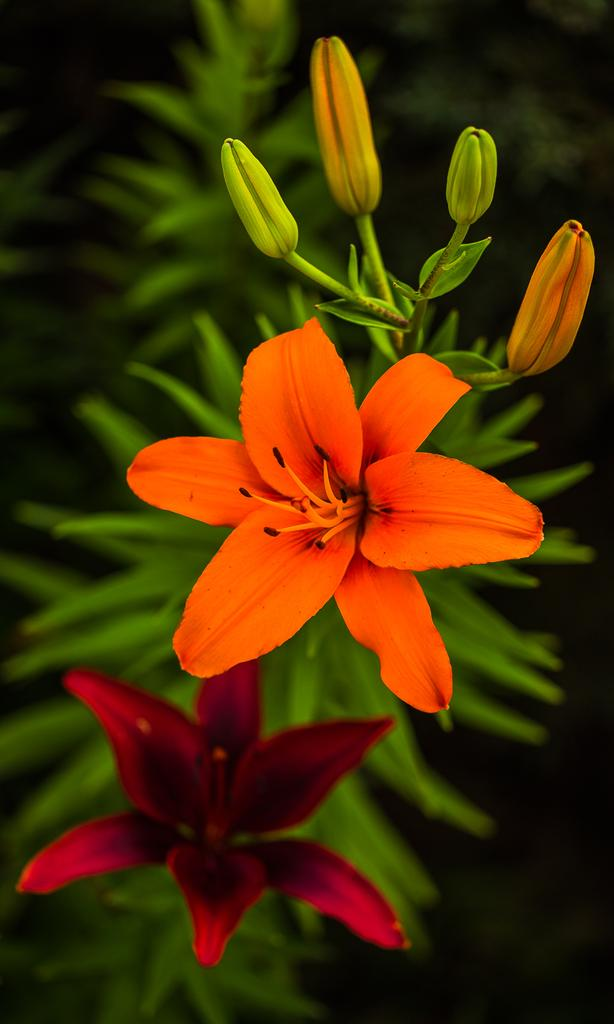What type of plant is visible in the image? There are flowers on a plant in the image. What else can be seen on the plant besides the flowers? There are leaves visible behind the flowers in the image. Where is the throne located in the image? There is no throne present in the image. What force is causing the flowers to grow in the image? The image does not provide information about the force causing the flowers to grow; it only shows the flowers and leaves. 